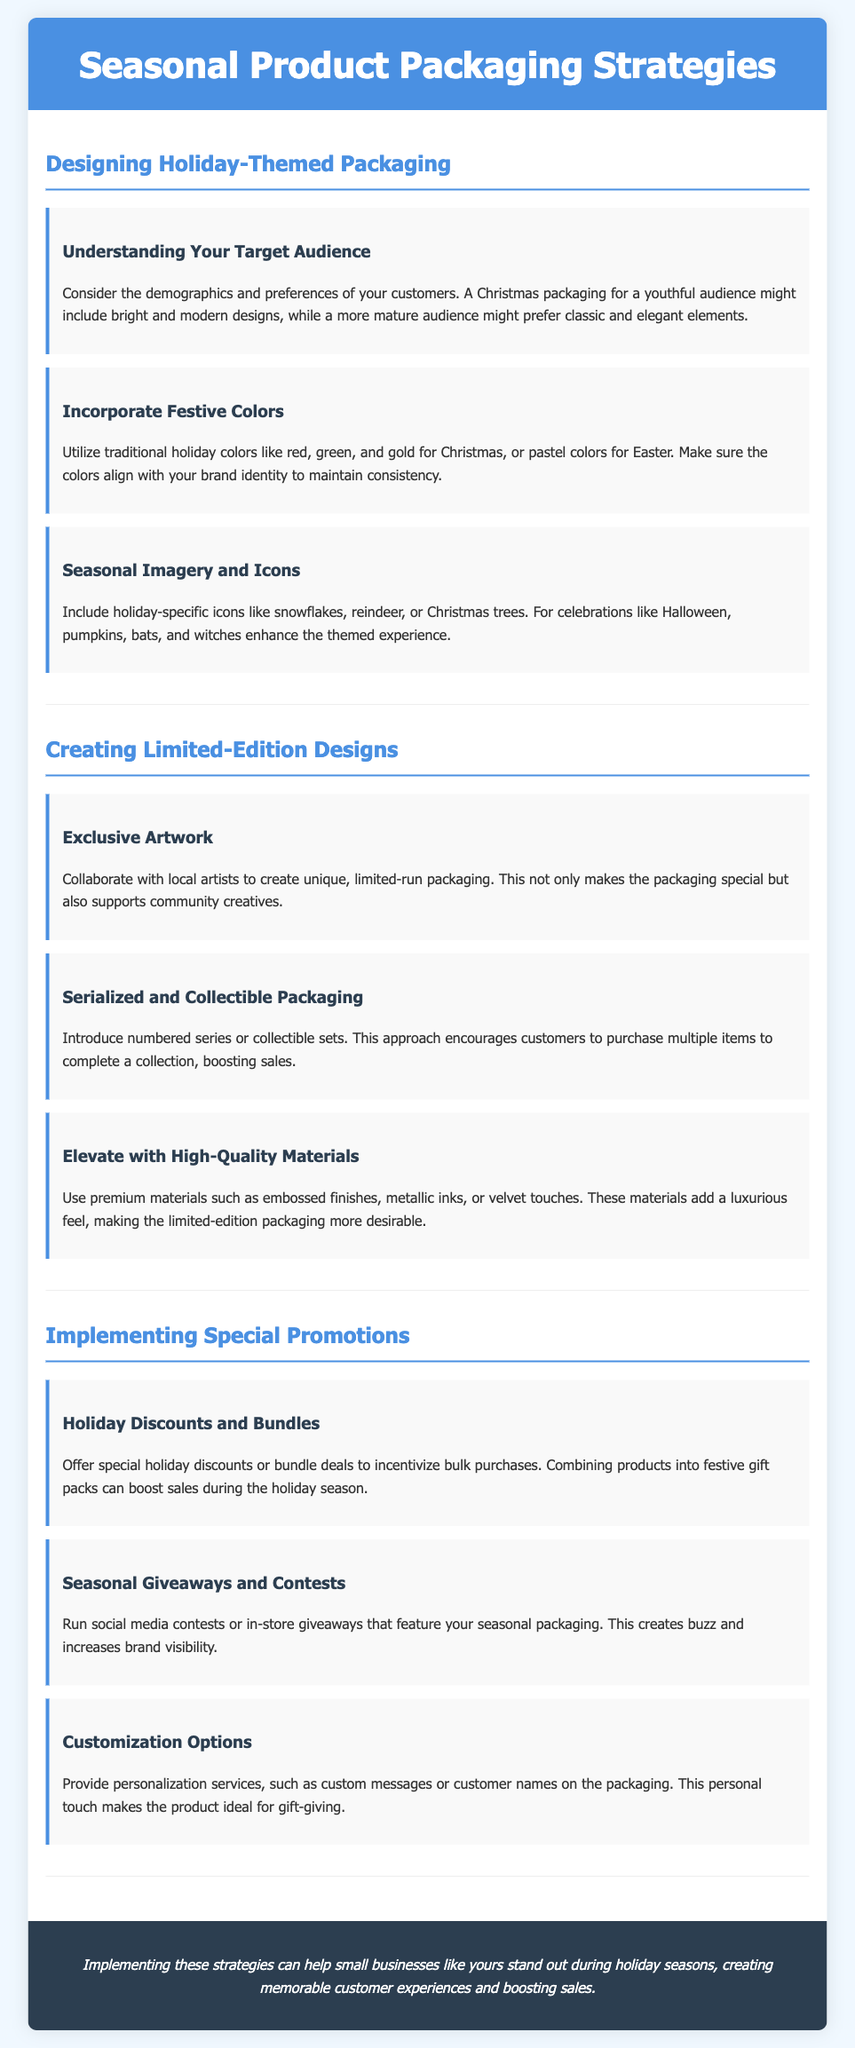What is the main focus of the document? The document focuses on strategies for seasonal product packaging, specifically during holidays.
Answer: Seasonal product packaging strategies What color scheme is suggested for holiday packaging? The document recommends using traditional holiday colors like red, green, and gold for Christmas.
Answer: Red, green, and gold What is one consideration when designing holiday-themed packaging? Understanding demographics and customer preferences is emphasized in the document for effective design.
Answer: Target audience What type of packaging is recommended for exclusive products? The document suggests creating limited-edition designs with exclusive artwork from local artists.
Answer: Exclusive artwork What promotional strategy involves offering bundled products? Offering holiday discounts and bundle deals is mentioned as a method to incentivize purchases.
Answer: Holiday discounts and bundles What effect does using premium materials have on packaging? High-quality materials elevate the packaging's desirability, making it more appealing to customers.
Answer: More desirable Which approach encourages customers to buy multiple items? Introducing serialized and collectible packaging encourages customers to purchase multiple items to complete a collection.
Answer: Serialized and collectible packaging What is a suggestion for increasing brand visibility during holidays? Running social media contests or in-store giveaways featuring seasonal packaging is recommended.
Answer: Seasonal giveaways and contests What personal touch is suggested for holiday packaging? Providing customization options, such as custom messages or names, adds a personal touch that is ideal for gifts.
Answer: Customization options 